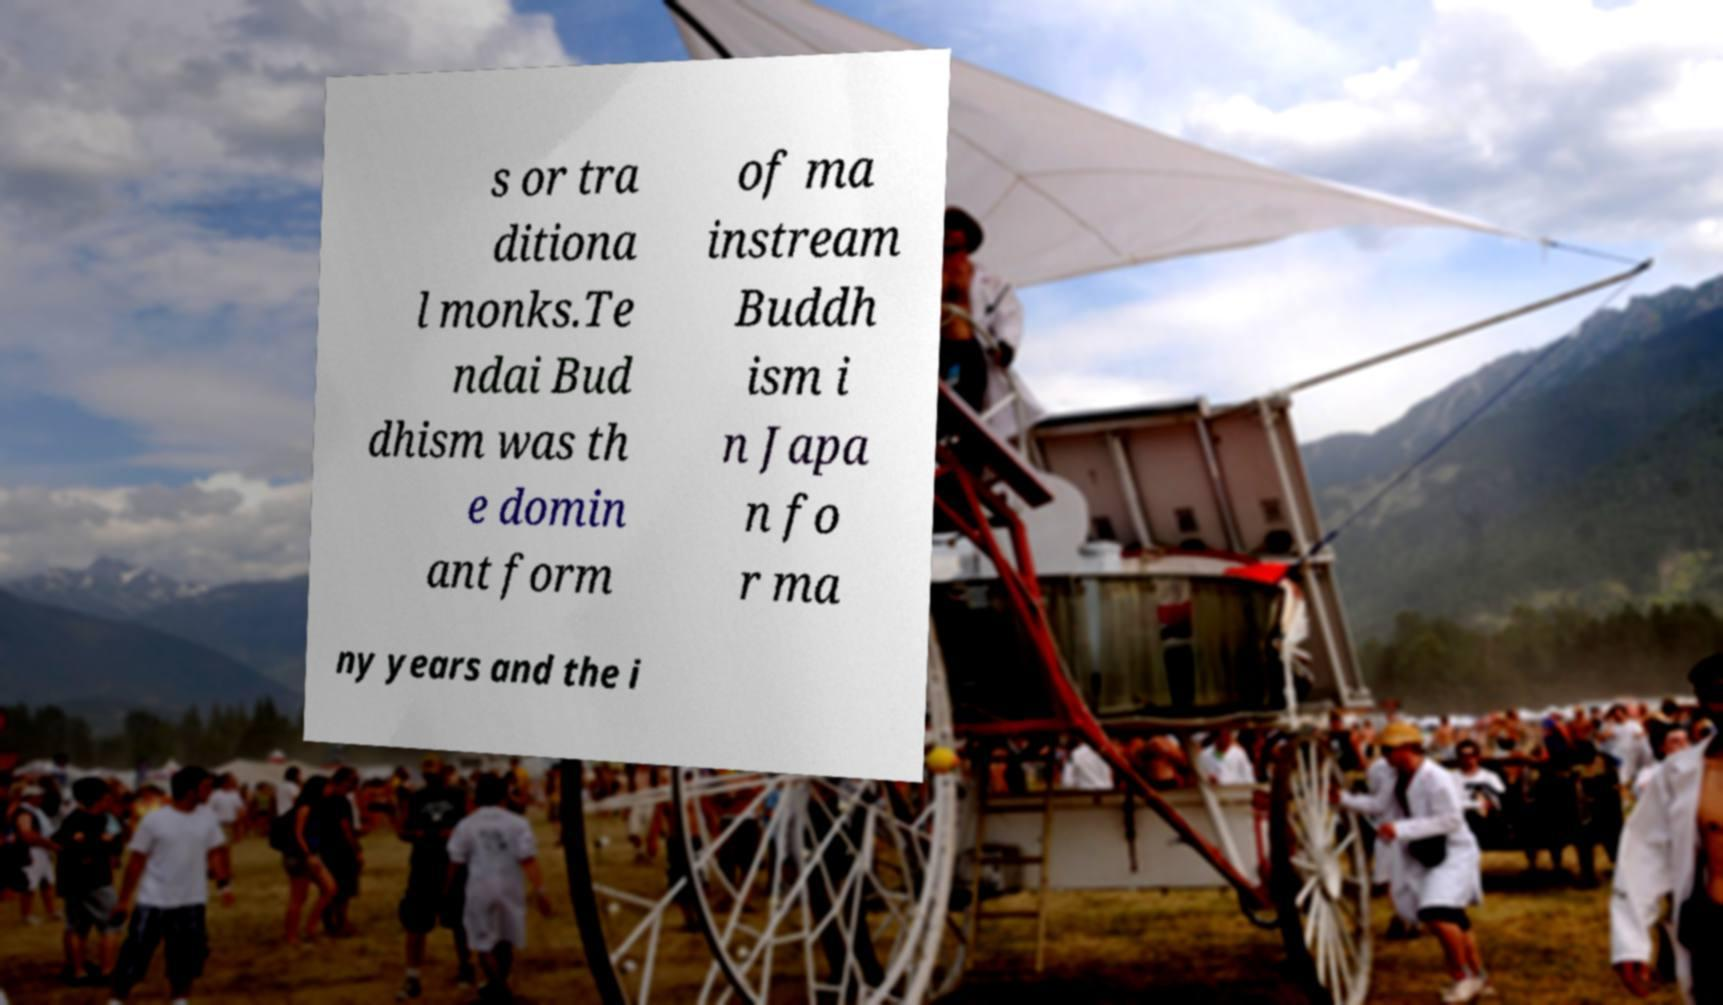Could you extract and type out the text from this image? s or tra ditiona l monks.Te ndai Bud dhism was th e domin ant form of ma instream Buddh ism i n Japa n fo r ma ny years and the i 